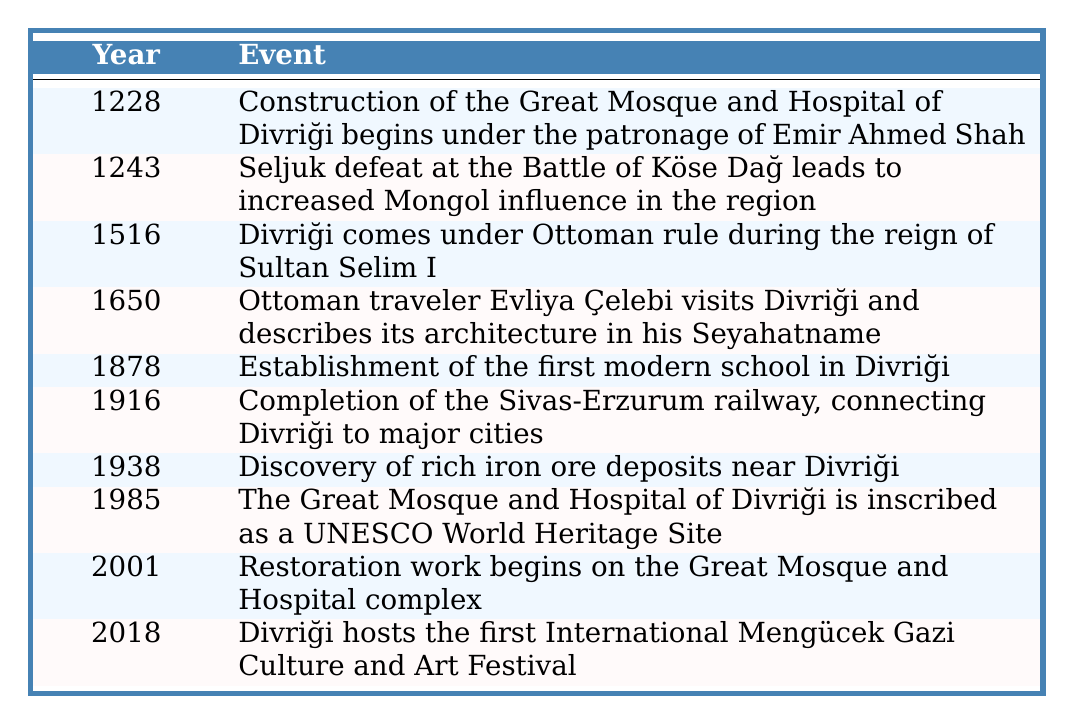What year did construction of the Great Mosque and Hospital of Divriği begin? The table shows that the construction began in the year 1228.
Answer: 1228 What significant event happened in Divriği in 1985? According to the table, in 1985, the Great Mosque and Hospital of Divriği was inscribed as a UNESCO World Heritage Site.
Answer: Inscribed as a UNESCO World Heritage Site What year did Divriği come under Ottoman rule? The table indicates that Divriği came under Ottoman rule in 1516.
Answer: 1516 In which year was the first modern school established in Divriği? The table specifies the year of establishment as 1878.
Answer: 1878 Which event that occurred in 1916 is related to infrastructure? The table states that in 1916, the Sivas-Erzurum railway was completed, connecting Divriği to major cities.
Answer: Completion of the Sivas-Erzurum railway What is the difference in years between the establishment of the first modern school and the inscription of the mosque as a UNESCO site? The first modern school was established in 1878 and the mosque was inscribed in 1985. The difference is 1985 - 1878 = 107 years.
Answer: 107 years Was Divriği influenced by the Mongols after the Battle of Köse Dağ? Yes, the table notes that the Seljuk defeat at the Battle of Köse Dağ in 1243 led to increased Mongol influence in the region.
Answer: Yes In what year did Evliya Çelebi visit Divriği? The table records that Evliya Çelebi visited Divriği in 1650.
Answer: 1650 How many years passed between the discovery of iron ore deposits and the first International Culture and Art Festival? The discovery of iron ore deposits occurred in 1938 and the festival in 2018. Therefore, 2018 - 1938 = 80 years passed.
Answer: 80 years What events occurred in Divriği during the 17th century? The table shows that the visit by Evliya Çelebi in 1650 occurred during the 17th century.
Answer: Evliya Çelebi's visit in 1650 